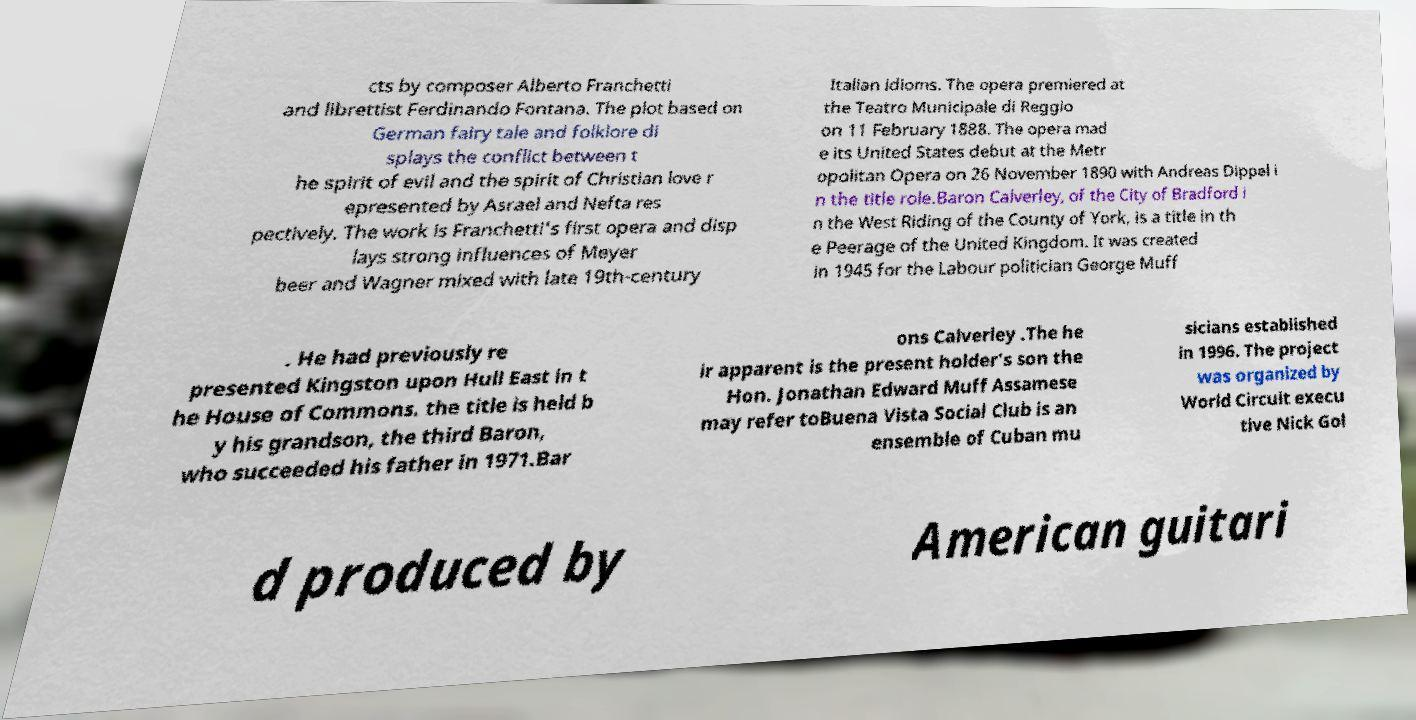Could you assist in decoding the text presented in this image and type it out clearly? cts by composer Alberto Franchetti and librettist Ferdinando Fontana. The plot based on German fairy tale and folklore di splays the conflict between t he spirit of evil and the spirit of Christian love r epresented by Asrael and Nefta res pectively. The work is Franchetti's first opera and disp lays strong influences of Meyer beer and Wagner mixed with late 19th-century Italian idioms. The opera premiered at the Teatro Municipale di Reggio on 11 February 1888. The opera mad e its United States debut at the Metr opolitan Opera on 26 November 1890 with Andreas Dippel i n the title role.Baron Calverley, of the City of Bradford i n the West Riding of the County of York, is a title in th e Peerage of the United Kingdom. It was created in 1945 for the Labour politician George Muff . He had previously re presented Kingston upon Hull East in t he House of Commons. the title is held b y his grandson, the third Baron, who succeeded his father in 1971.Bar ons Calverley .The he ir apparent is the present holder's son the Hon. Jonathan Edward Muff Assamese may refer toBuena Vista Social Club is an ensemble of Cuban mu sicians established in 1996. The project was organized by World Circuit execu tive Nick Gol d produced by American guitari 